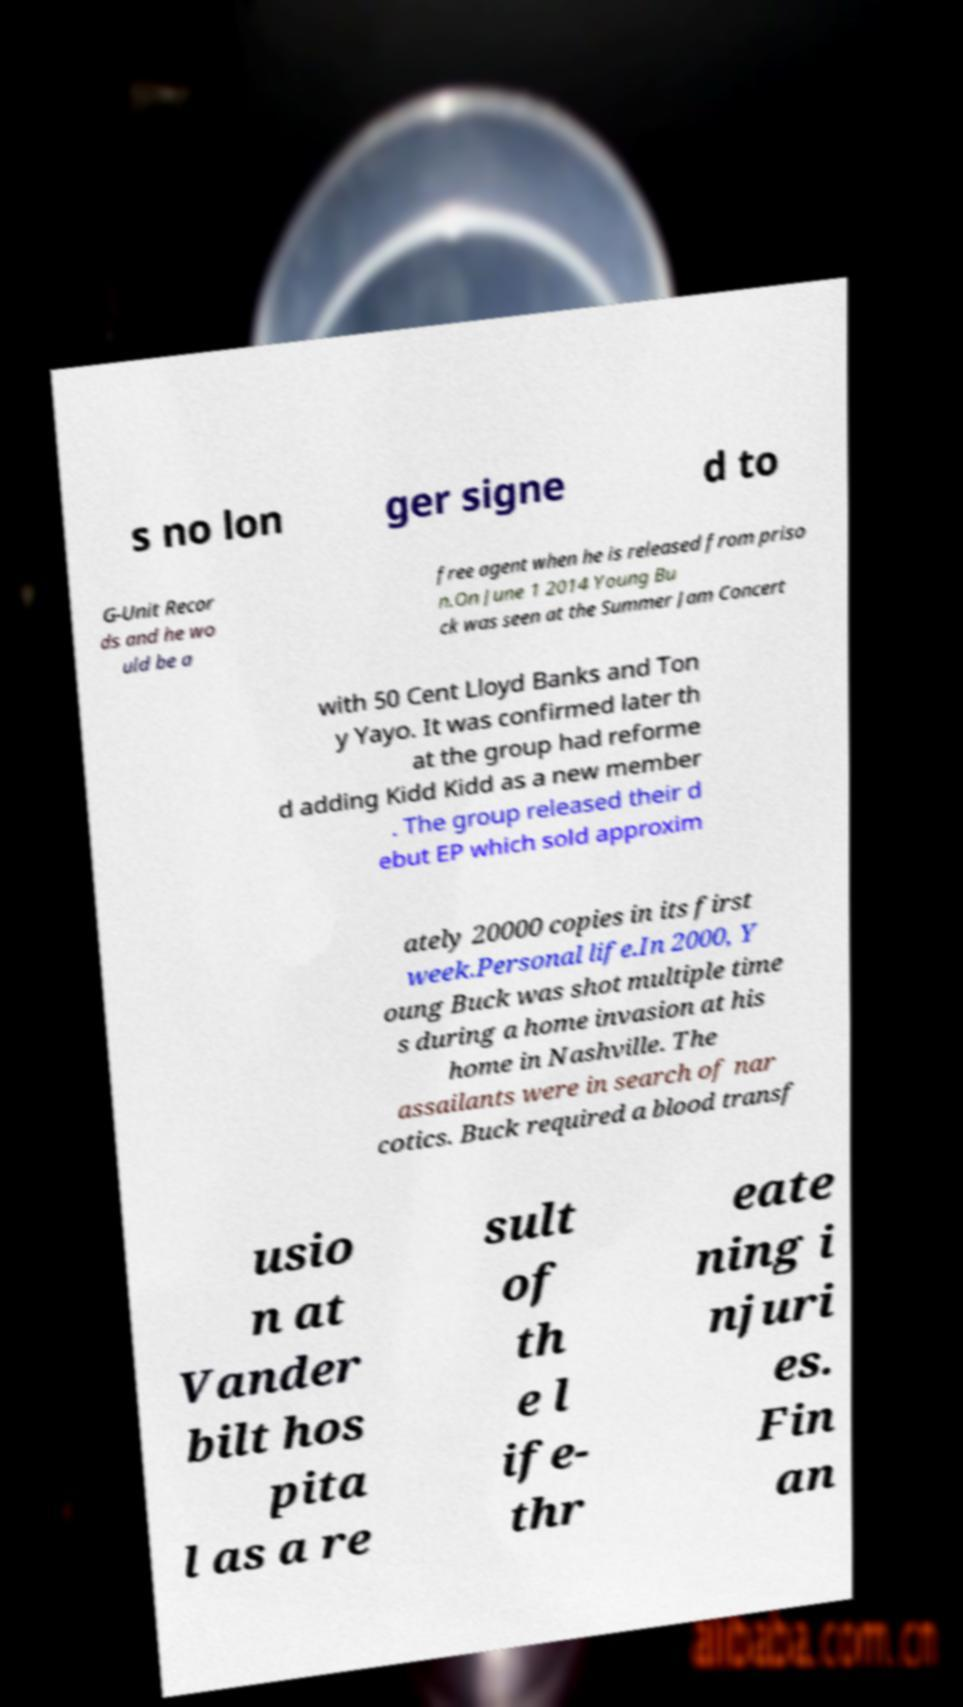Can you read and provide the text displayed in the image?This photo seems to have some interesting text. Can you extract and type it out for me? s no lon ger signe d to G-Unit Recor ds and he wo uld be a free agent when he is released from priso n.On June 1 2014 Young Bu ck was seen at the Summer Jam Concert with 50 Cent Lloyd Banks and Ton y Yayo. It was confirmed later th at the group had reforme d adding Kidd Kidd as a new member . The group released their d ebut EP which sold approxim ately 20000 copies in its first week.Personal life.In 2000, Y oung Buck was shot multiple time s during a home invasion at his home in Nashville. The assailants were in search of nar cotics. Buck required a blood transf usio n at Vander bilt hos pita l as a re sult of th e l ife- thr eate ning i njuri es. Fin an 